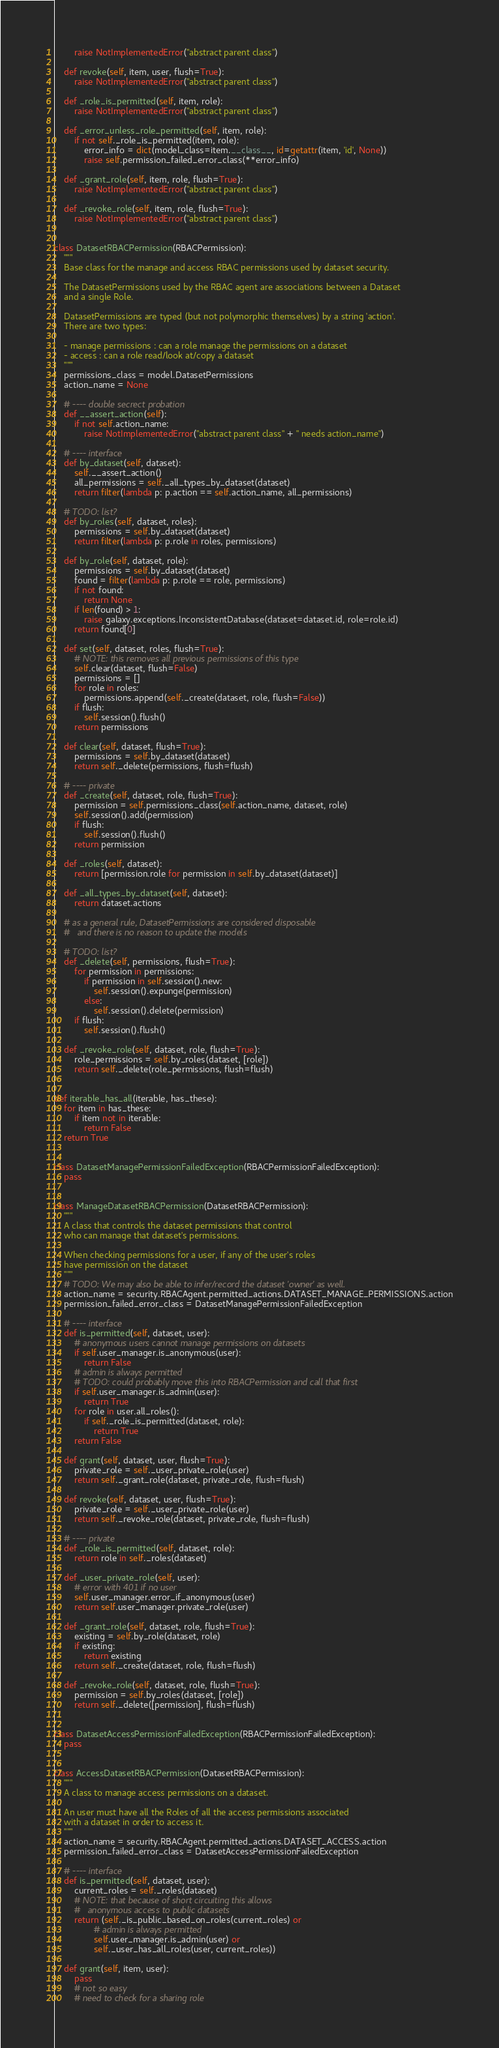<code> <loc_0><loc_0><loc_500><loc_500><_Python_>        raise NotImplementedError("abstract parent class")

    def revoke(self, item, user, flush=True):
        raise NotImplementedError("abstract parent class")

    def _role_is_permitted(self, item, role):
        raise NotImplementedError("abstract parent class")

    def _error_unless_role_permitted(self, item, role):
        if not self._role_is_permitted(item, role):
            error_info = dict(model_class=item.__class__, id=getattr(item, 'id', None))
            raise self.permission_failed_error_class(**error_info)

    def _grant_role(self, item, role, flush=True):
        raise NotImplementedError("abstract parent class")

    def _revoke_role(self, item, role, flush=True):
        raise NotImplementedError("abstract parent class")


class DatasetRBACPermission(RBACPermission):
    """
    Base class for the manage and access RBAC permissions used by dataset security.

    The DatasetPermissions used by the RBAC agent are associations between a Dataset
    and a single Role.

    DatasetPermissions are typed (but not polymorphic themselves) by a string 'action'.
    There are two types:

    - manage permissions : can a role manage the permissions on a dataset
    - access : can a role read/look at/copy a dataset
    """
    permissions_class = model.DatasetPermissions
    action_name = None

    # ---- double secrect probation
    def __assert_action(self):
        if not self.action_name:
            raise NotImplementedError("abstract parent class" + " needs action_name")

    # ---- interface
    def by_dataset(self, dataset):
        self.__assert_action()
        all_permissions = self._all_types_by_dataset(dataset)
        return filter(lambda p: p.action == self.action_name, all_permissions)

    # TODO: list?
    def by_roles(self, dataset, roles):
        permissions = self.by_dataset(dataset)
        return filter(lambda p: p.role in roles, permissions)

    def by_role(self, dataset, role):
        permissions = self.by_dataset(dataset)
        found = filter(lambda p: p.role == role, permissions)
        if not found:
            return None
        if len(found) > 1:
            raise galaxy.exceptions.InconsistentDatabase(dataset=dataset.id, role=role.id)
        return found[0]

    def set(self, dataset, roles, flush=True):
        # NOTE: this removes all previous permissions of this type
        self.clear(dataset, flush=False)
        permissions = []
        for role in roles:
            permissions.append(self._create(dataset, role, flush=False))
        if flush:
            self.session().flush()
        return permissions

    def clear(self, dataset, flush=True):
        permissions = self.by_dataset(dataset)
        return self._delete(permissions, flush=flush)

    # ---- private
    def _create(self, dataset, role, flush=True):
        permission = self.permissions_class(self.action_name, dataset, role)
        self.session().add(permission)
        if flush:
            self.session().flush()
        return permission

    def _roles(self, dataset):
        return [permission.role for permission in self.by_dataset(dataset)]

    def _all_types_by_dataset(self, dataset):
        return dataset.actions

    # as a general rule, DatasetPermissions are considered disposable
    #   and there is no reason to update the models

    # TODO: list?
    def _delete(self, permissions, flush=True):
        for permission in permissions:
            if permission in self.session().new:
                self.session().expunge(permission)
            else:
                self.session().delete(permission)
        if flush:
            self.session().flush()

    def _revoke_role(self, dataset, role, flush=True):
        role_permissions = self.by_roles(dataset, [role])
        return self._delete(role_permissions, flush=flush)


def iterable_has_all(iterable, has_these):
    for item in has_these:
        if item not in iterable:
            return False
    return True


class DatasetManagePermissionFailedException(RBACPermissionFailedException):
    pass


class ManageDatasetRBACPermission(DatasetRBACPermission):
    """
    A class that controls the dataset permissions that control
    who can manage that dataset's permissions.

    When checking permissions for a user, if any of the user's roles
    have permission on the dataset
    """
    # TODO: We may also be able to infer/record the dataset 'owner' as well.
    action_name = security.RBACAgent.permitted_actions.DATASET_MANAGE_PERMISSIONS.action
    permission_failed_error_class = DatasetManagePermissionFailedException

    # ---- interface
    def is_permitted(self, dataset, user):
        # anonymous users cannot manage permissions on datasets
        if self.user_manager.is_anonymous(user):
            return False
        # admin is always permitted
        # TODO: could probably move this into RBACPermission and call that first
        if self.user_manager.is_admin(user):
            return True
        for role in user.all_roles():
            if self._role_is_permitted(dataset, role):
                return True
        return False

    def grant(self, dataset, user, flush=True):
        private_role = self._user_private_role(user)
        return self._grant_role(dataset, private_role, flush=flush)

    def revoke(self, dataset, user, flush=True):
        private_role = self._user_private_role(user)
        return self._revoke_role(dataset, private_role, flush=flush)

    # ---- private
    def _role_is_permitted(self, dataset, role):
        return role in self._roles(dataset)

    def _user_private_role(self, user):
        # error with 401 if no user
        self.user_manager.error_if_anonymous(user)
        return self.user_manager.private_role(user)

    def _grant_role(self, dataset, role, flush=True):
        existing = self.by_role(dataset, role)
        if existing:
            return existing
        return self._create(dataset, role, flush=flush)

    def _revoke_role(self, dataset, role, flush=True):
        permission = self.by_roles(dataset, [role])
        return self._delete([permission], flush=flush)


class DatasetAccessPermissionFailedException(RBACPermissionFailedException):
    pass


class AccessDatasetRBACPermission(DatasetRBACPermission):
    """
    A class to manage access permissions on a dataset.

    An user must have all the Roles of all the access permissions associated
    with a dataset in order to access it.
    """
    action_name = security.RBACAgent.permitted_actions.DATASET_ACCESS.action
    permission_failed_error_class = DatasetAccessPermissionFailedException

    # ---- interface
    def is_permitted(self, dataset, user):
        current_roles = self._roles(dataset)
        # NOTE: that because of short circuiting this allows
        #   anonymous access to public datasets
        return (self._is_public_based_on_roles(current_roles) or
                # admin is always permitted
                self.user_manager.is_admin(user) or
                self._user_has_all_roles(user, current_roles))

    def grant(self, item, user):
        pass
        # not so easy
        # need to check for a sharing role</code> 